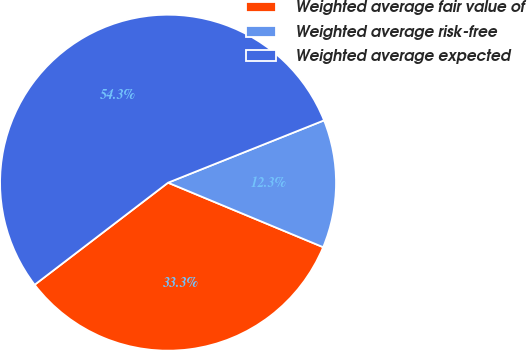Convert chart. <chart><loc_0><loc_0><loc_500><loc_500><pie_chart><fcel>Weighted average fair value of<fcel>Weighted average risk-free<fcel>Weighted average expected<nl><fcel>33.33%<fcel>12.32%<fcel>54.34%<nl></chart> 